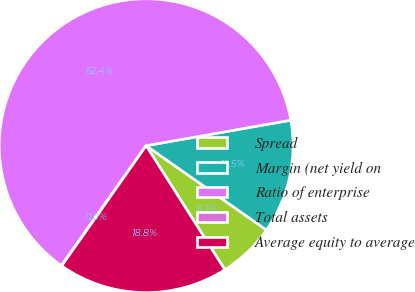Convert chart. <chart><loc_0><loc_0><loc_500><loc_500><pie_chart><fcel>Spread<fcel>Margin (net yield on<fcel>Ratio of enterprise<fcel>Total assets<fcel>Average equity to average<nl><fcel>6.27%<fcel>12.51%<fcel>62.43%<fcel>0.04%<fcel>18.75%<nl></chart> 